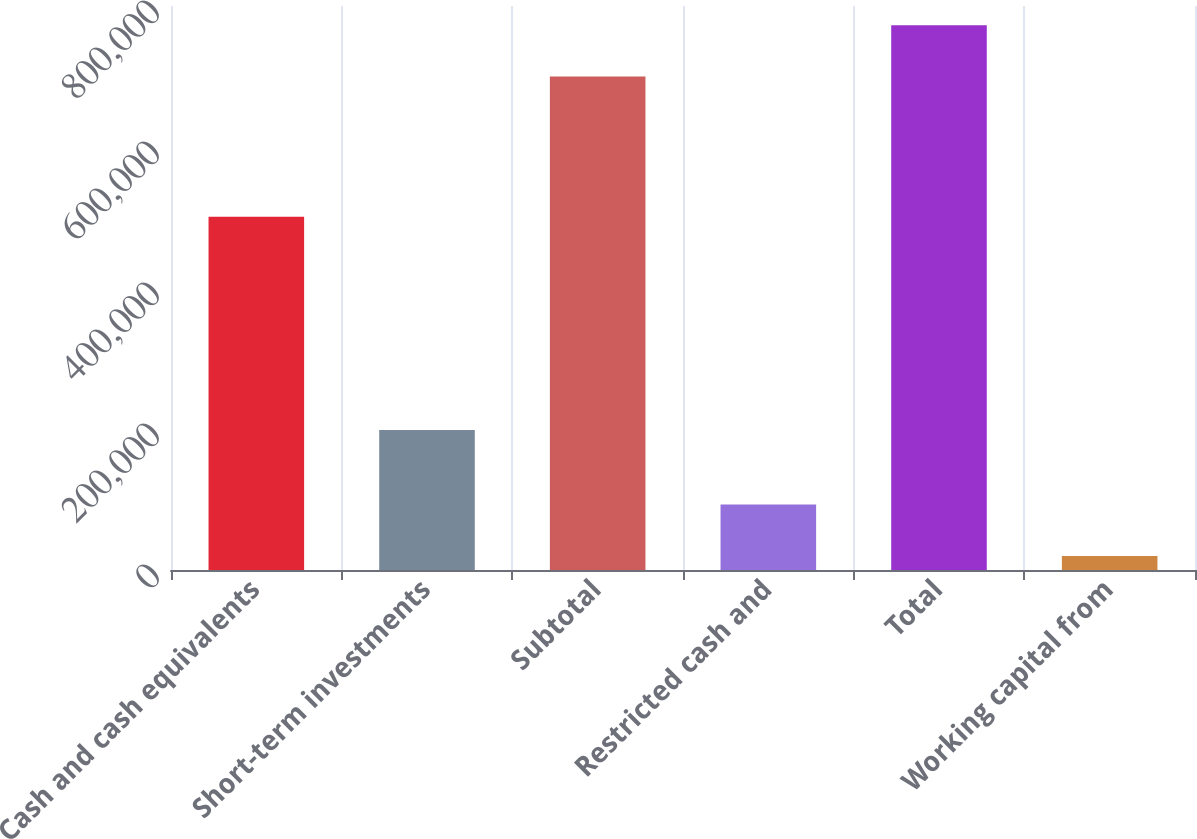<chart> <loc_0><loc_0><loc_500><loc_500><bar_chart><fcel>Cash and cash equivalents<fcel>Short-term investments<fcel>Subtotal<fcel>Restricted cash and<fcel>Total<fcel>Working capital from<nl><fcel>501184<fcel>198656<fcel>699840<fcel>92838.6<fcel>772778<fcel>19901<nl></chart> 